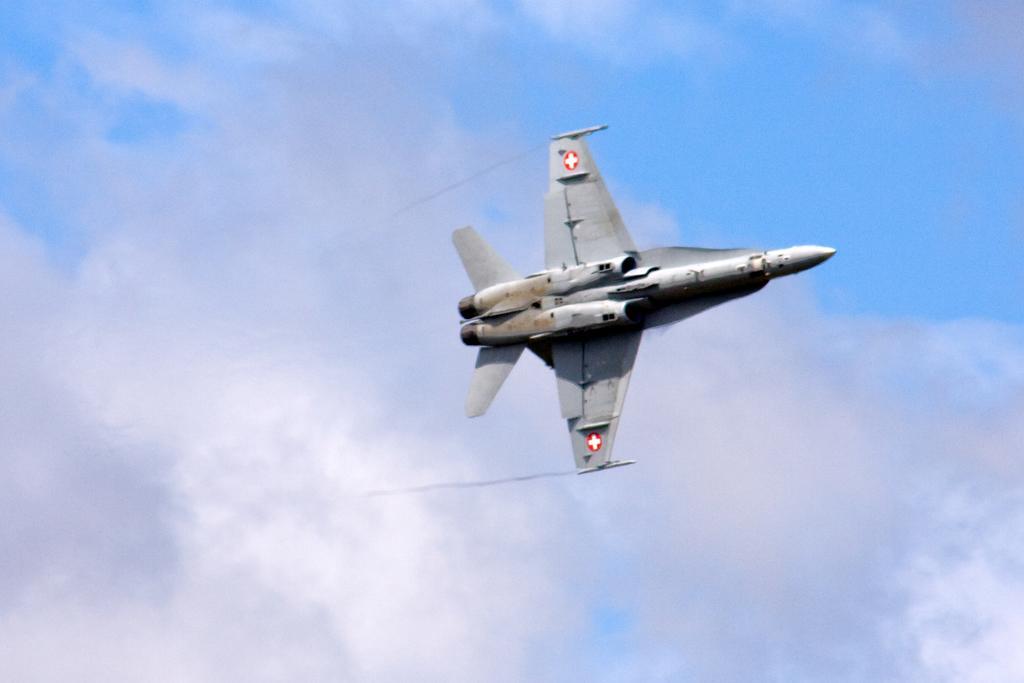Please provide a concise description of this image. In the image there is a jet plane flying in the sky, the sky is filled with clouds. 